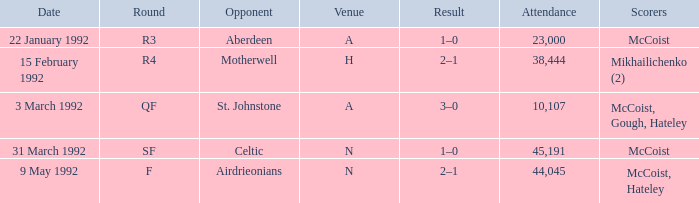What is the result of round R3? 1–0. 